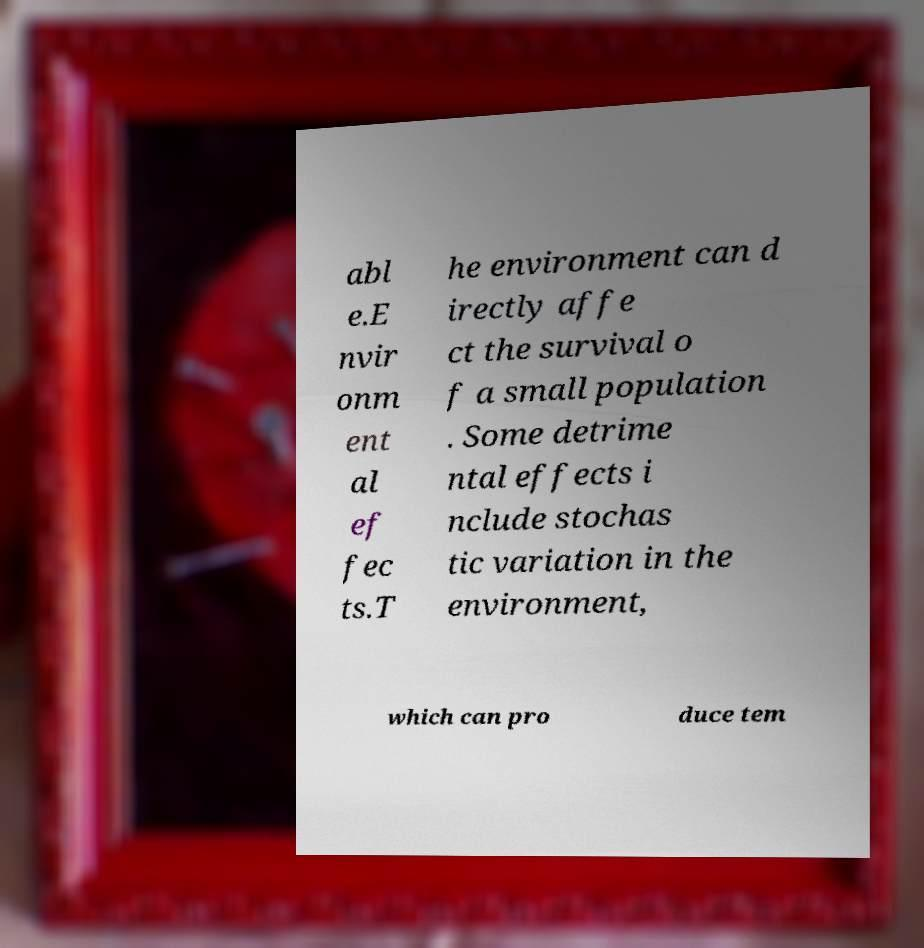Please identify and transcribe the text found in this image. abl e.E nvir onm ent al ef fec ts.T he environment can d irectly affe ct the survival o f a small population . Some detrime ntal effects i nclude stochas tic variation in the environment, which can pro duce tem 